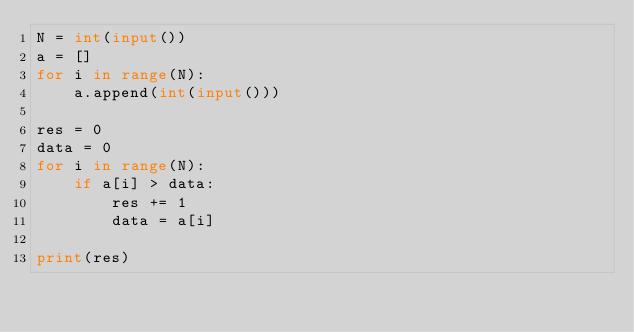<code> <loc_0><loc_0><loc_500><loc_500><_Python_>N = int(input())
a = []
for i in range(N):
    a.append(int(input()))

res = 0
data = 0
for i in range(N):
    if a[i] > data:
        res += 1
        data = a[i]

print(res)</code> 